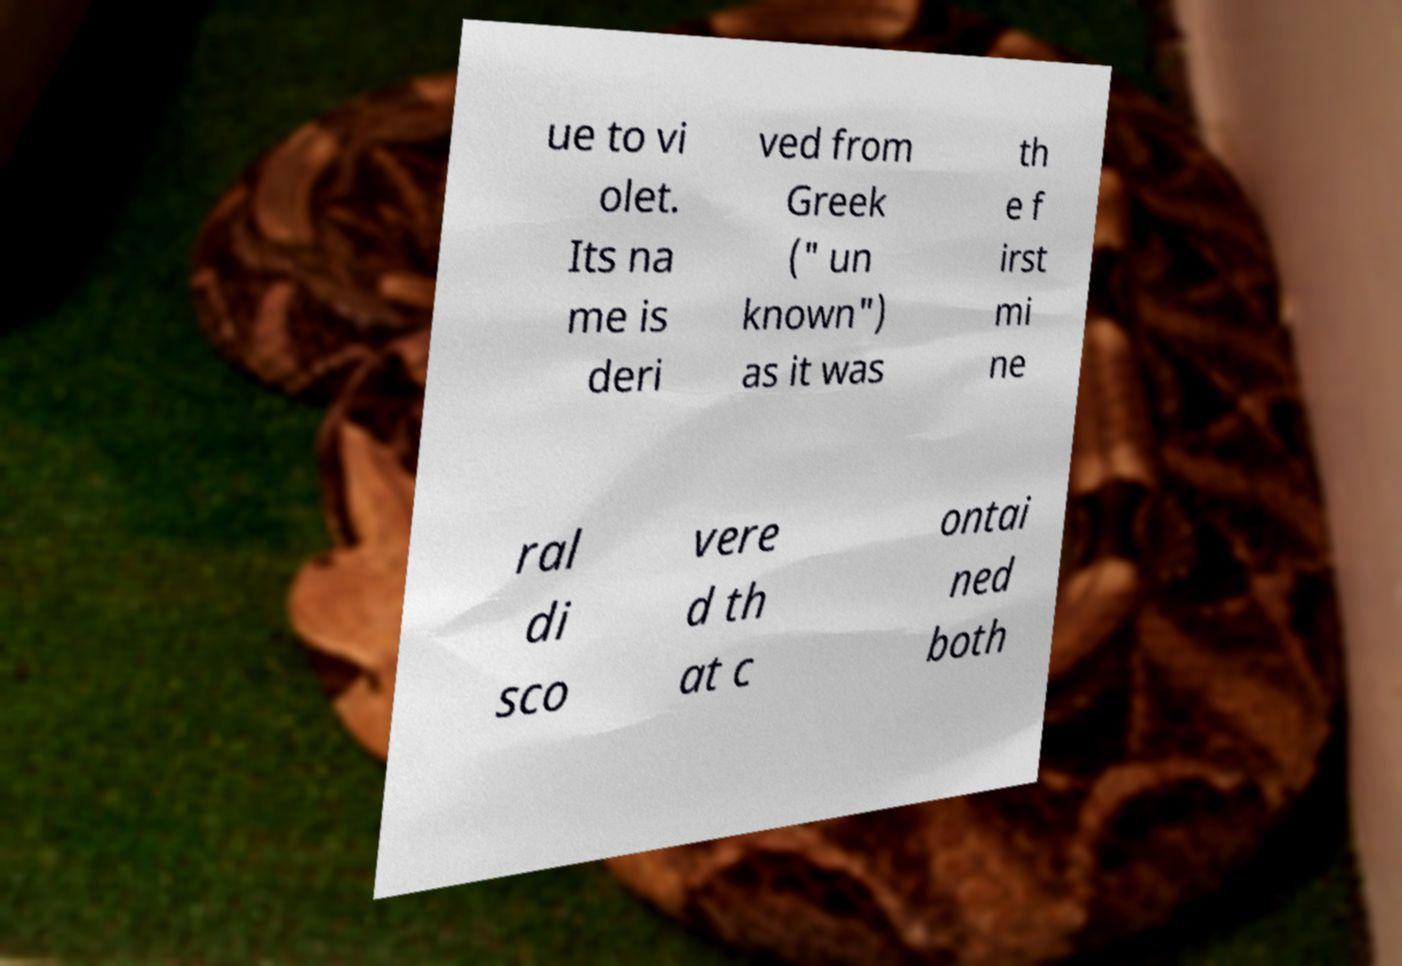Could you extract and type out the text from this image? ue to vi olet. Its na me is deri ved from Greek (" un known") as it was th e f irst mi ne ral di sco vere d th at c ontai ned both 